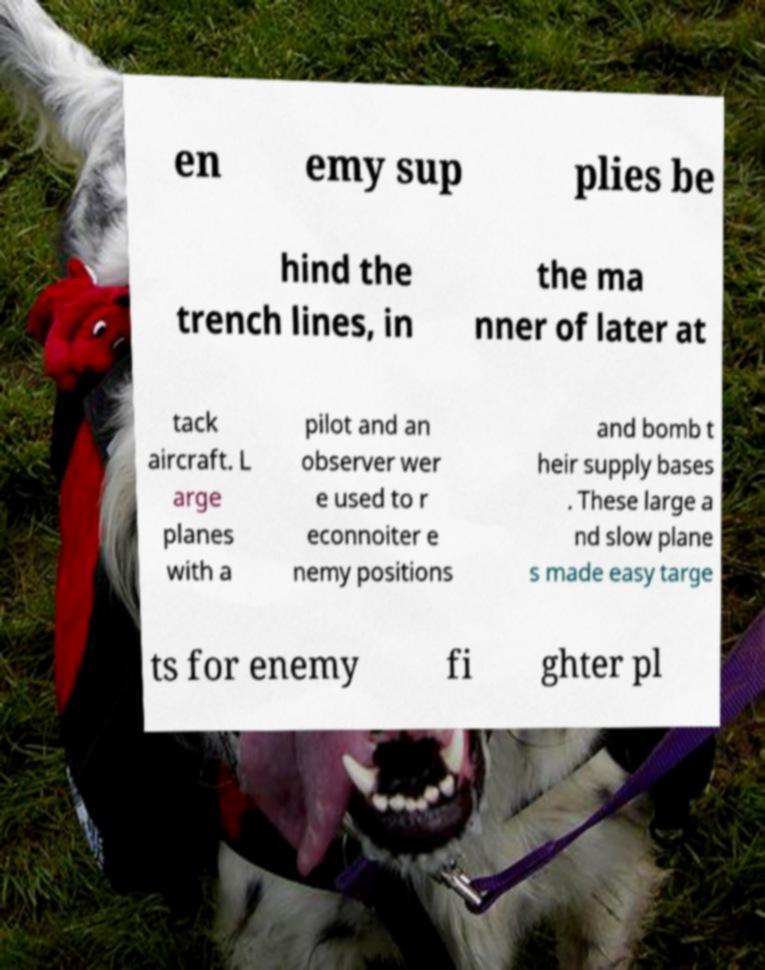Could you assist in decoding the text presented in this image and type it out clearly? en emy sup plies be hind the trench lines, in the ma nner of later at tack aircraft. L arge planes with a pilot and an observer wer e used to r econnoiter e nemy positions and bomb t heir supply bases . These large a nd slow plane s made easy targe ts for enemy fi ghter pl 